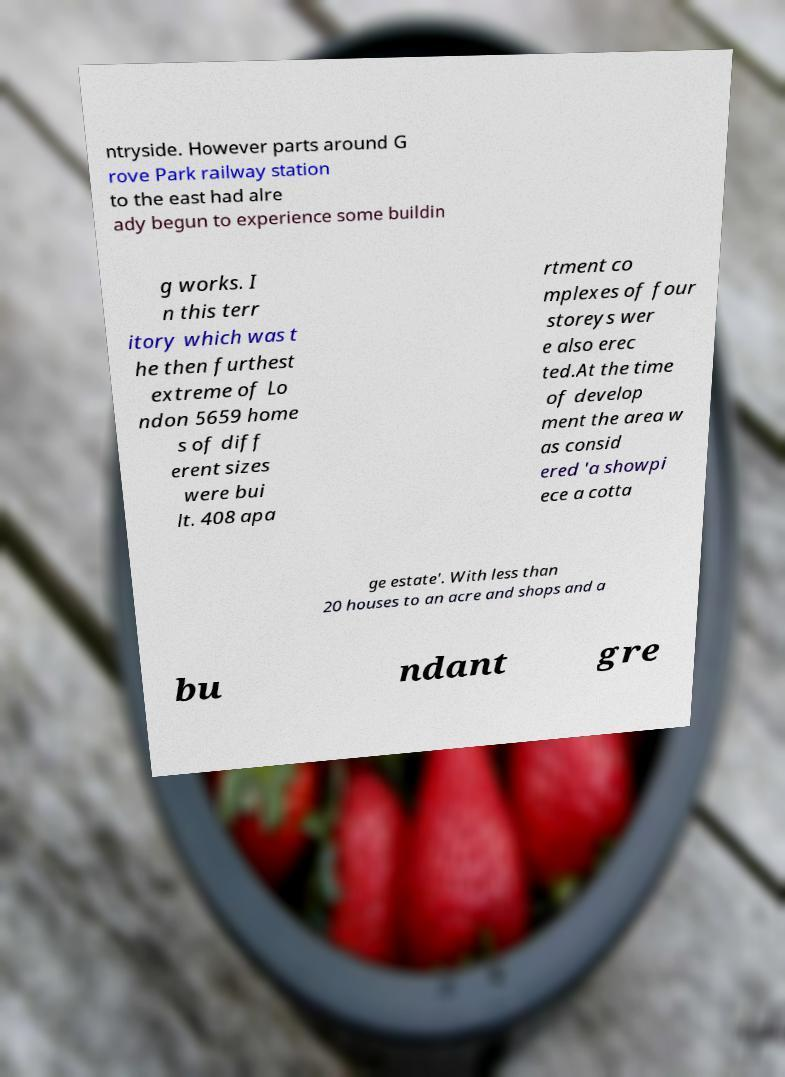Please identify and transcribe the text found in this image. ntryside. However parts around G rove Park railway station to the east had alre ady begun to experience some buildin g works. I n this terr itory which was t he then furthest extreme of Lo ndon 5659 home s of diff erent sizes were bui lt. 408 apa rtment co mplexes of four storeys wer e also erec ted.At the time of develop ment the area w as consid ered 'a showpi ece a cotta ge estate'. With less than 20 houses to an acre and shops and a bu ndant gre 